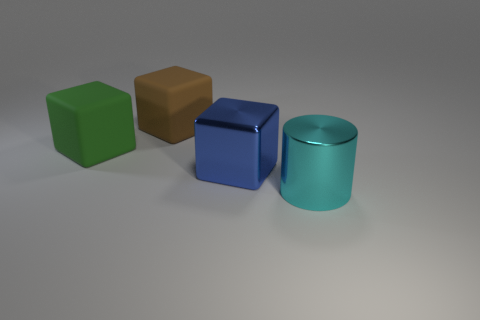There is a brown thing that is the same size as the green matte object; what is it made of?
Offer a very short reply. Rubber. There is a big block that is on the right side of the matte cube behind the green rubber cube; are there any big blue shiny cubes that are right of it?
Make the answer very short. No. Is there any other thing that is the same shape as the brown matte object?
Your answer should be very brief. Yes. Does the large metal thing to the left of the cyan shiny thing have the same color as the big thing that is in front of the metallic cube?
Offer a very short reply. No. Is there a large green cylinder?
Make the answer very short. No. There is a object to the right of the big metal thing that is behind the big object in front of the big blue shiny thing; what size is it?
Offer a terse response. Large. Does the large cyan shiny thing have the same shape as the shiny thing that is behind the big cyan metallic thing?
Provide a short and direct response. No. Are there any other shiny cylinders of the same color as the large cylinder?
Your response must be concise. No. How many blocks are big cyan objects or big green objects?
Ensure brevity in your answer.  1. Is there another cyan thing that has the same shape as the cyan object?
Ensure brevity in your answer.  No. 